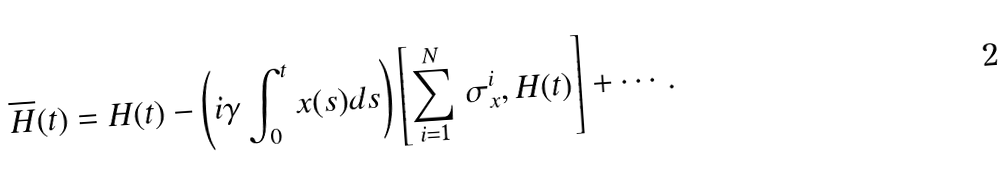Convert formula to latex. <formula><loc_0><loc_0><loc_500><loc_500>\overline { H } ( t ) = H ( t ) - \left ( i \gamma \int _ { 0 } ^ { t } x ( s ) d s \right ) \left [ \sum _ { i = 1 } ^ { N } \, \sigma _ { x } ^ { i } , H ( t ) \right ] + \cdots .</formula> 